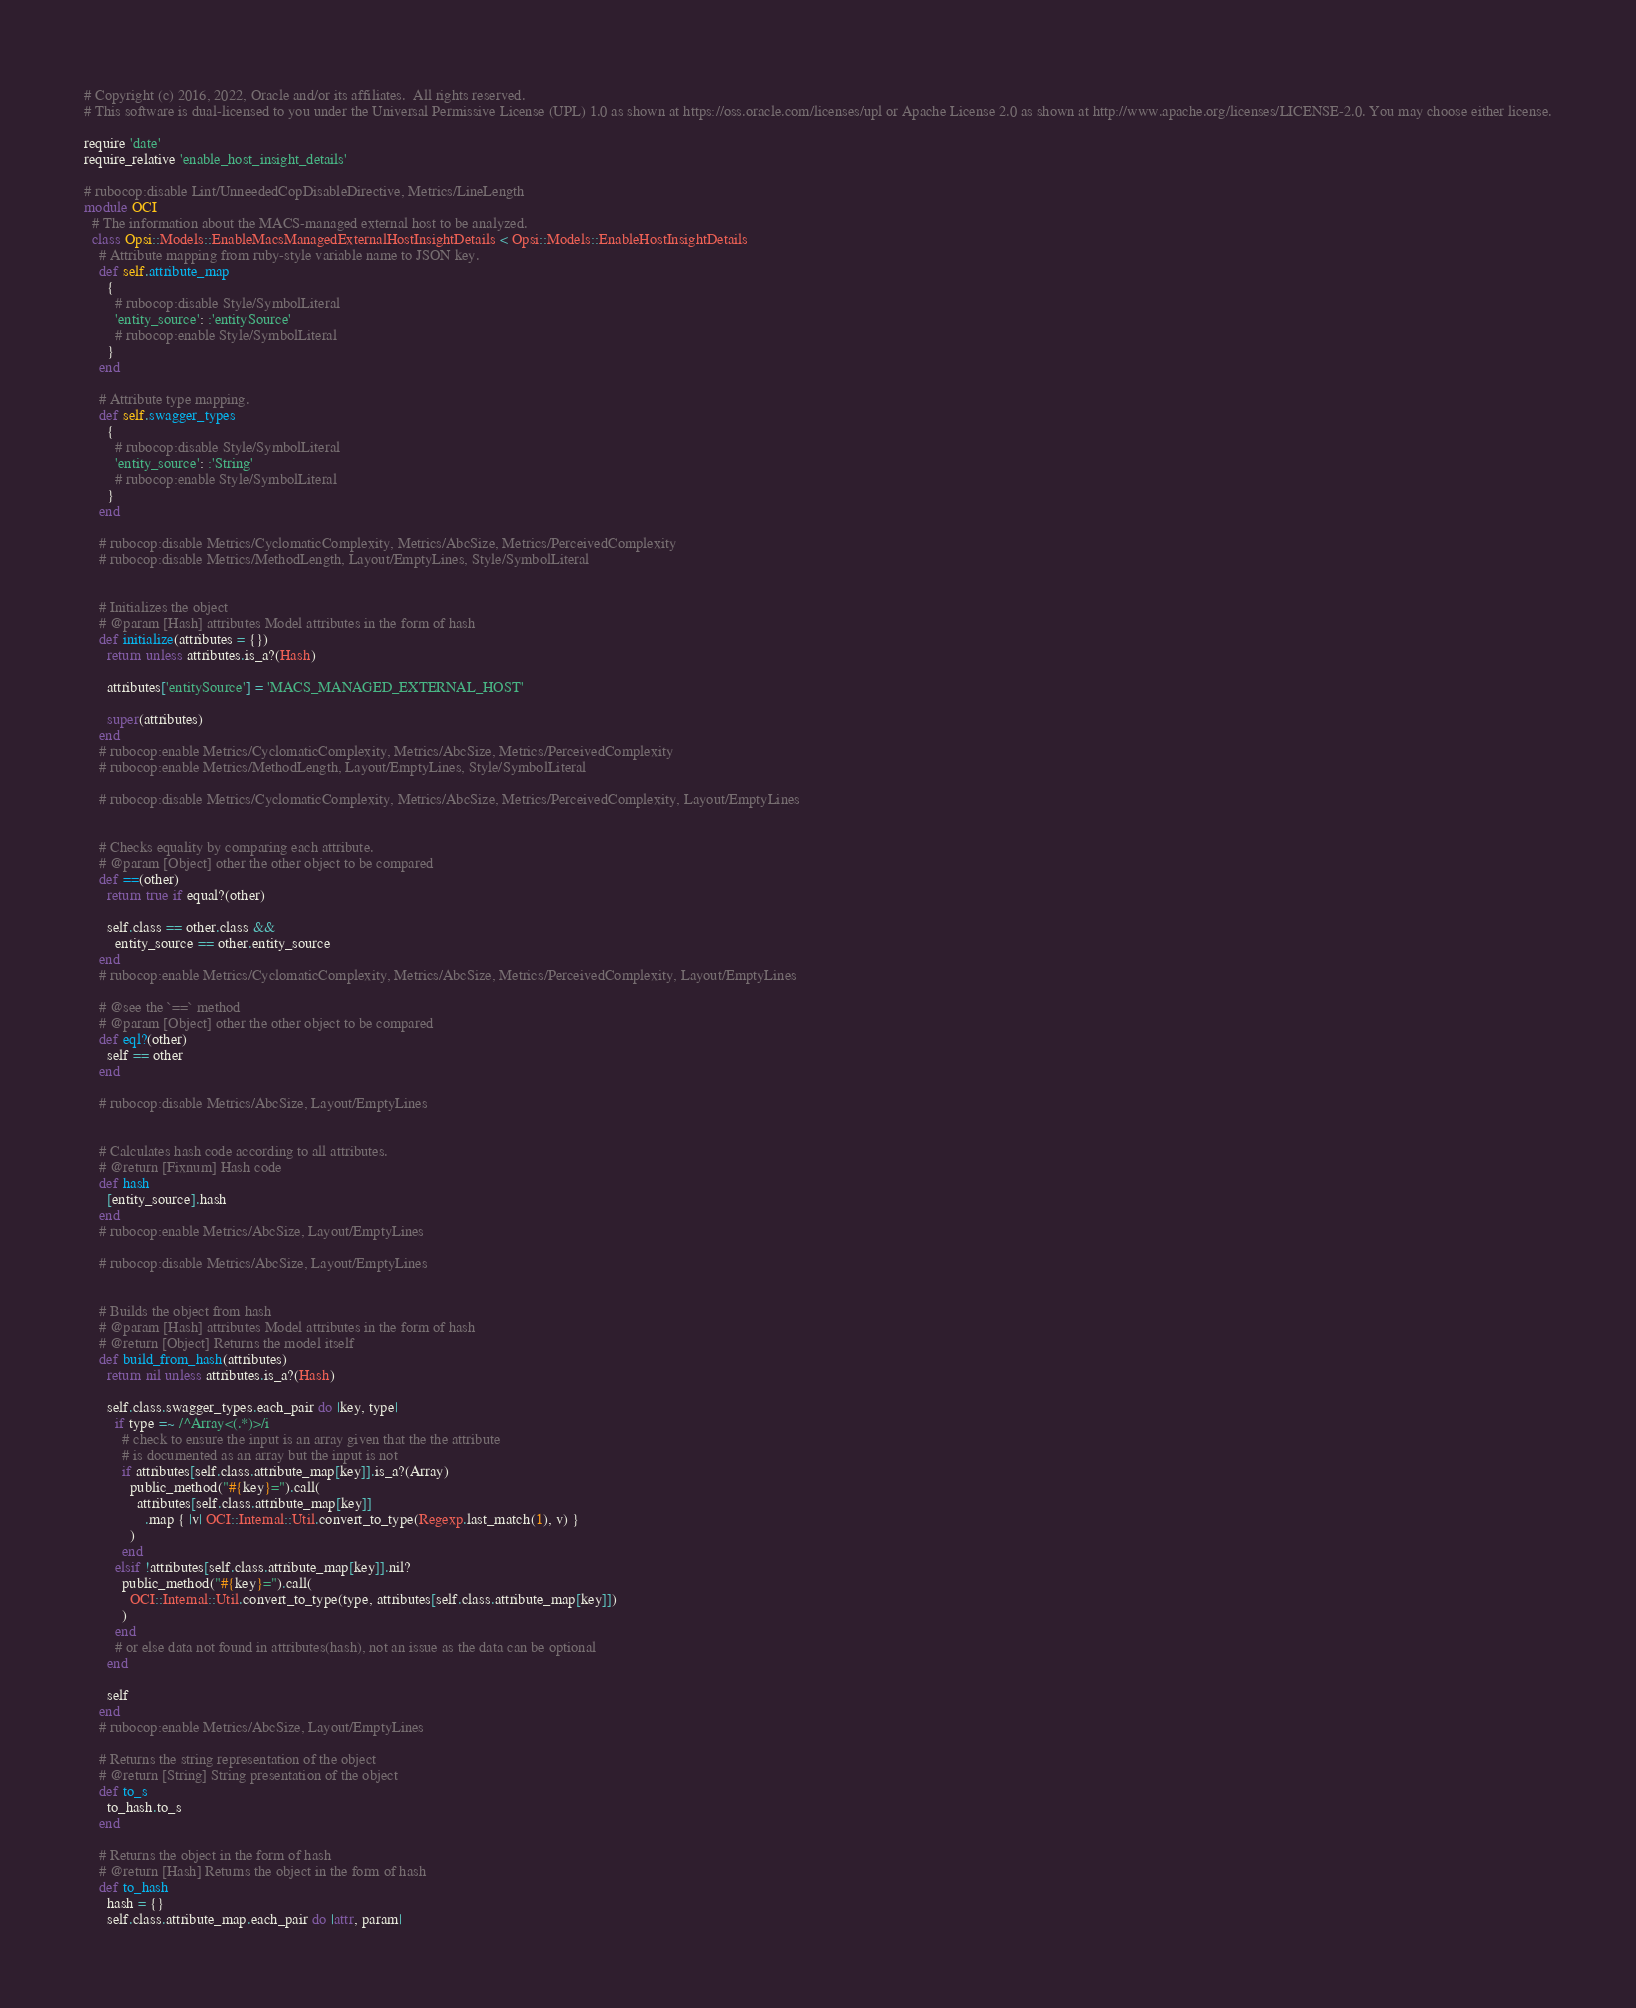<code> <loc_0><loc_0><loc_500><loc_500><_Ruby_># Copyright (c) 2016, 2022, Oracle and/or its affiliates.  All rights reserved.
# This software is dual-licensed to you under the Universal Permissive License (UPL) 1.0 as shown at https://oss.oracle.com/licenses/upl or Apache License 2.0 as shown at http://www.apache.org/licenses/LICENSE-2.0. You may choose either license.

require 'date'
require_relative 'enable_host_insight_details'

# rubocop:disable Lint/UnneededCopDisableDirective, Metrics/LineLength
module OCI
  # The information about the MACS-managed external host to be analyzed.
  class Opsi::Models::EnableMacsManagedExternalHostInsightDetails < Opsi::Models::EnableHostInsightDetails
    # Attribute mapping from ruby-style variable name to JSON key.
    def self.attribute_map
      {
        # rubocop:disable Style/SymbolLiteral
        'entity_source': :'entitySource'
        # rubocop:enable Style/SymbolLiteral
      }
    end

    # Attribute type mapping.
    def self.swagger_types
      {
        # rubocop:disable Style/SymbolLiteral
        'entity_source': :'String'
        # rubocop:enable Style/SymbolLiteral
      }
    end

    # rubocop:disable Metrics/CyclomaticComplexity, Metrics/AbcSize, Metrics/PerceivedComplexity
    # rubocop:disable Metrics/MethodLength, Layout/EmptyLines, Style/SymbolLiteral


    # Initializes the object
    # @param [Hash] attributes Model attributes in the form of hash
    def initialize(attributes = {})
      return unless attributes.is_a?(Hash)

      attributes['entitySource'] = 'MACS_MANAGED_EXTERNAL_HOST'

      super(attributes)
    end
    # rubocop:enable Metrics/CyclomaticComplexity, Metrics/AbcSize, Metrics/PerceivedComplexity
    # rubocop:enable Metrics/MethodLength, Layout/EmptyLines, Style/SymbolLiteral

    # rubocop:disable Metrics/CyclomaticComplexity, Metrics/AbcSize, Metrics/PerceivedComplexity, Layout/EmptyLines


    # Checks equality by comparing each attribute.
    # @param [Object] other the other object to be compared
    def ==(other)
      return true if equal?(other)

      self.class == other.class &&
        entity_source == other.entity_source
    end
    # rubocop:enable Metrics/CyclomaticComplexity, Metrics/AbcSize, Metrics/PerceivedComplexity, Layout/EmptyLines

    # @see the `==` method
    # @param [Object] other the other object to be compared
    def eql?(other)
      self == other
    end

    # rubocop:disable Metrics/AbcSize, Layout/EmptyLines


    # Calculates hash code according to all attributes.
    # @return [Fixnum] Hash code
    def hash
      [entity_source].hash
    end
    # rubocop:enable Metrics/AbcSize, Layout/EmptyLines

    # rubocop:disable Metrics/AbcSize, Layout/EmptyLines


    # Builds the object from hash
    # @param [Hash] attributes Model attributes in the form of hash
    # @return [Object] Returns the model itself
    def build_from_hash(attributes)
      return nil unless attributes.is_a?(Hash)

      self.class.swagger_types.each_pair do |key, type|
        if type =~ /^Array<(.*)>/i
          # check to ensure the input is an array given that the the attribute
          # is documented as an array but the input is not
          if attributes[self.class.attribute_map[key]].is_a?(Array)
            public_method("#{key}=").call(
              attributes[self.class.attribute_map[key]]
                .map { |v| OCI::Internal::Util.convert_to_type(Regexp.last_match(1), v) }
            )
          end
        elsif !attributes[self.class.attribute_map[key]].nil?
          public_method("#{key}=").call(
            OCI::Internal::Util.convert_to_type(type, attributes[self.class.attribute_map[key]])
          )
        end
        # or else data not found in attributes(hash), not an issue as the data can be optional
      end

      self
    end
    # rubocop:enable Metrics/AbcSize, Layout/EmptyLines

    # Returns the string representation of the object
    # @return [String] String presentation of the object
    def to_s
      to_hash.to_s
    end

    # Returns the object in the form of hash
    # @return [Hash] Returns the object in the form of hash
    def to_hash
      hash = {}
      self.class.attribute_map.each_pair do |attr, param|</code> 